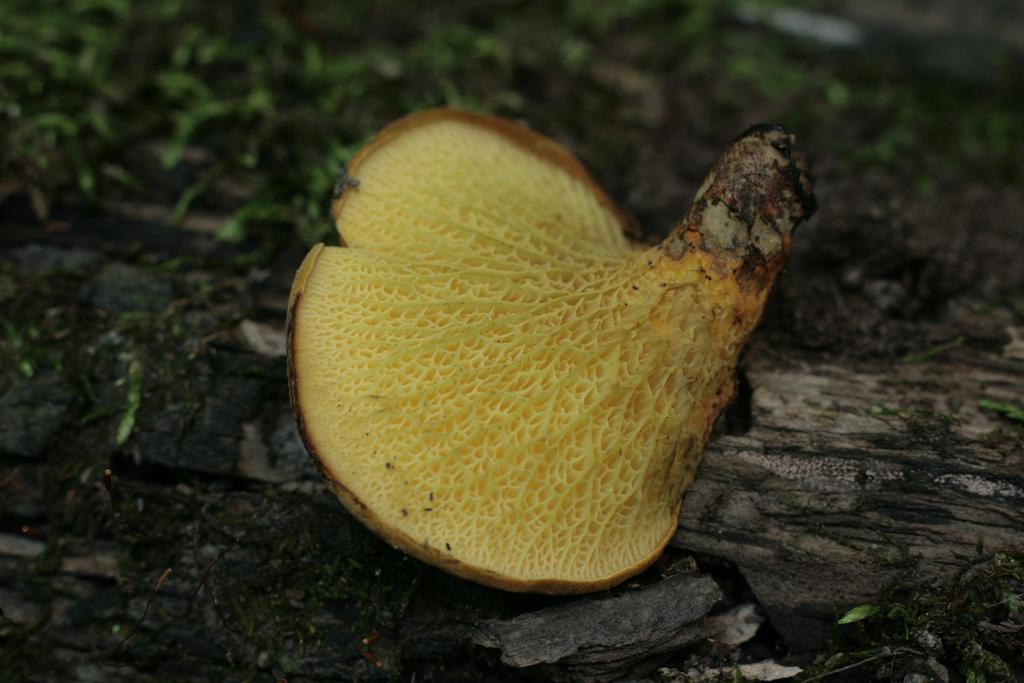What object in the image resembles a mushroom? There is an object in the image that resembles a mushroom. Where is the mushroom-like object located? The mushroom-like object is on a tree trunk. Can you describe the background of the image? The background of the image is blurred. What type of ray is swimming in the stream in the image? There is no ray or stream present in the image; it features a mushroom-like object on a tree trunk with a blurred background. 